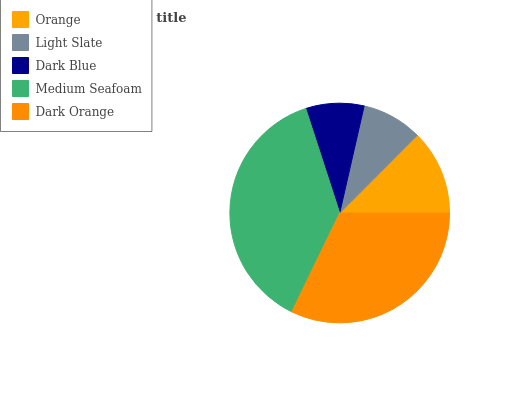Is Dark Blue the minimum?
Answer yes or no. Yes. Is Medium Seafoam the maximum?
Answer yes or no. Yes. Is Light Slate the minimum?
Answer yes or no. No. Is Light Slate the maximum?
Answer yes or no. No. Is Orange greater than Light Slate?
Answer yes or no. Yes. Is Light Slate less than Orange?
Answer yes or no. Yes. Is Light Slate greater than Orange?
Answer yes or no. No. Is Orange less than Light Slate?
Answer yes or no. No. Is Orange the high median?
Answer yes or no. Yes. Is Orange the low median?
Answer yes or no. Yes. Is Light Slate the high median?
Answer yes or no. No. Is Dark Orange the low median?
Answer yes or no. No. 